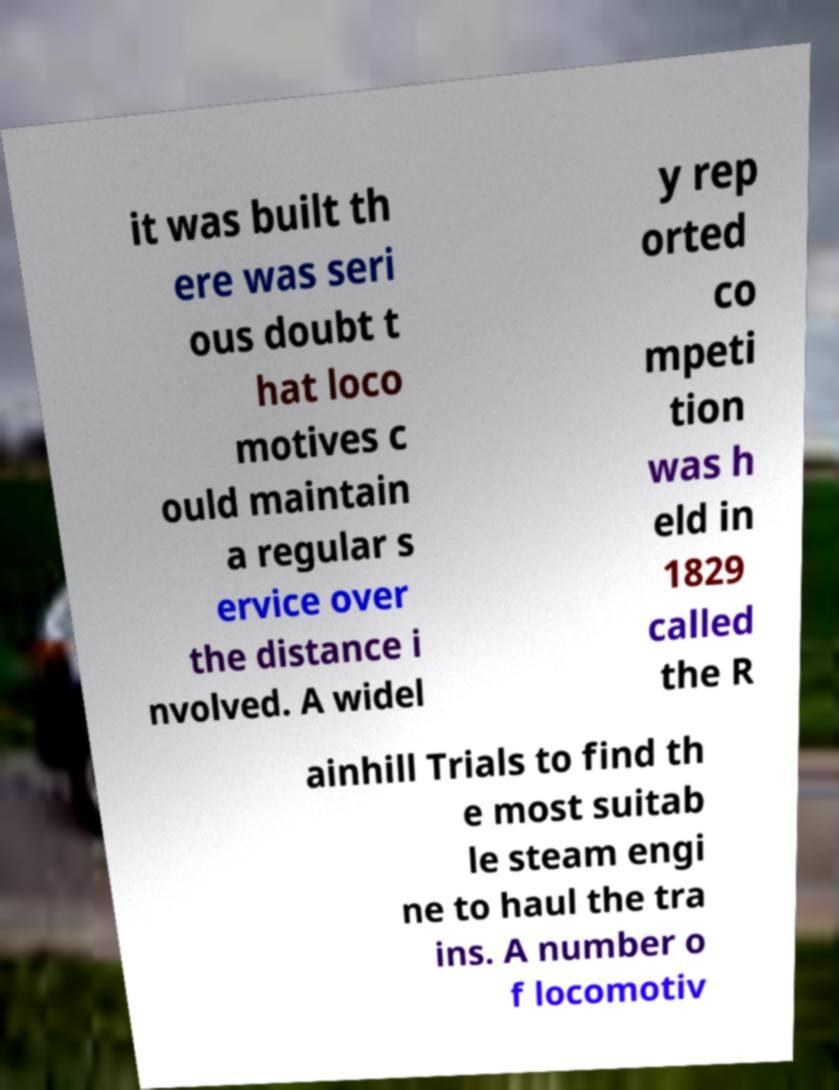For documentation purposes, I need the text within this image transcribed. Could you provide that? it was built th ere was seri ous doubt t hat loco motives c ould maintain a regular s ervice over the distance i nvolved. A widel y rep orted co mpeti tion was h eld in 1829 called the R ainhill Trials to find th e most suitab le steam engi ne to haul the tra ins. A number o f locomotiv 